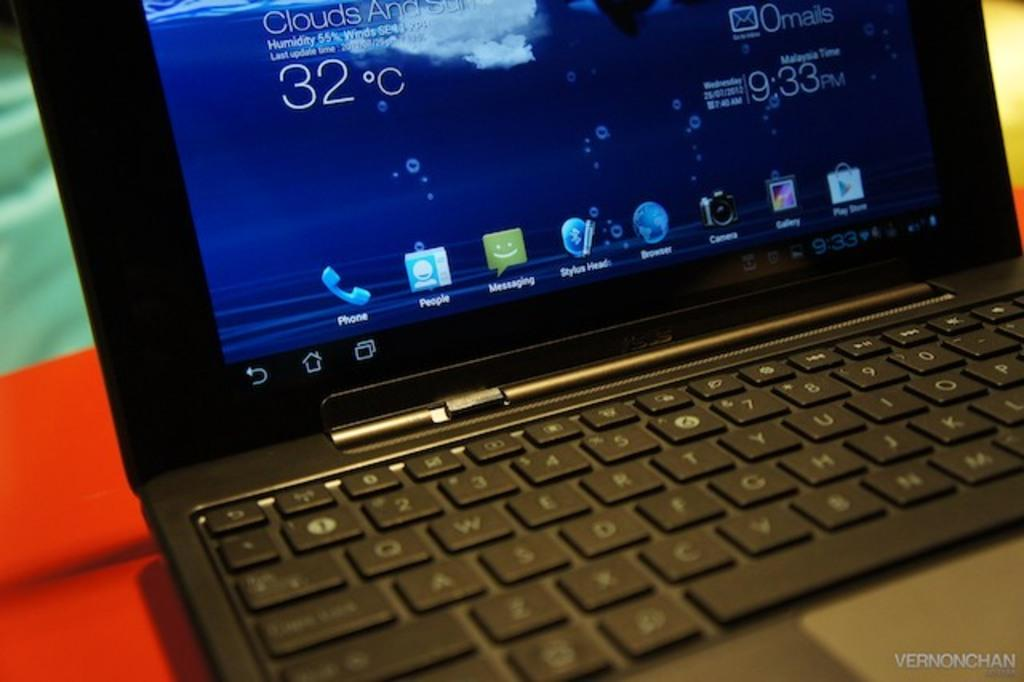<image>
Write a terse but informative summary of the picture. a laptop is open to its home screen, showing 32 degrees Celsius 